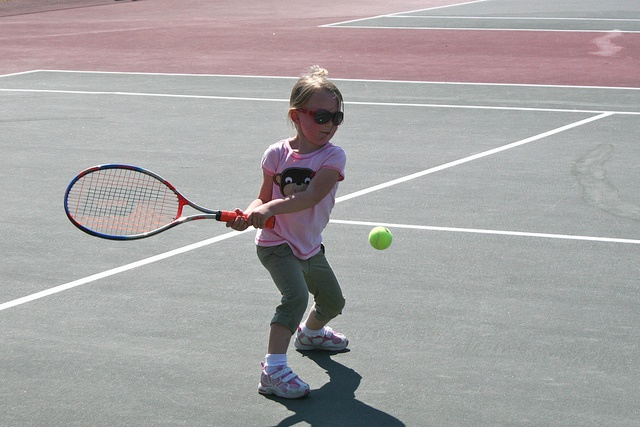Describe the objects in this image and their specific colors. I can see people in gray, black, and maroon tones, tennis racket in gray, darkgray, lightpink, lightgray, and black tones, and sports ball in gray, green, lightyellow, and lightgreen tones in this image. 